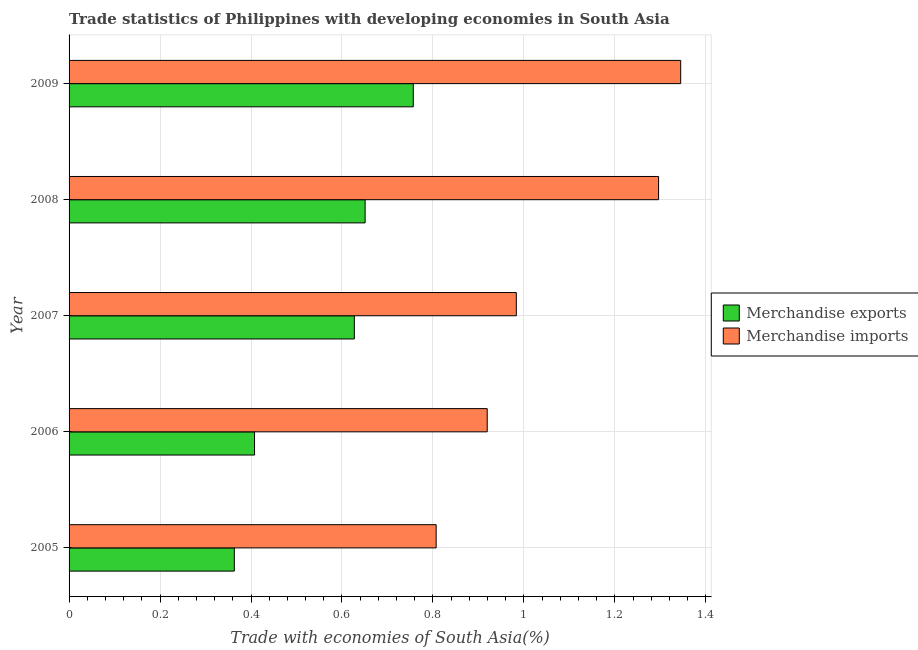How many different coloured bars are there?
Your response must be concise. 2. How many groups of bars are there?
Keep it short and to the point. 5. Are the number of bars per tick equal to the number of legend labels?
Provide a succinct answer. Yes. Are the number of bars on each tick of the Y-axis equal?
Provide a short and direct response. Yes. How many bars are there on the 2nd tick from the top?
Offer a terse response. 2. How many bars are there on the 5th tick from the bottom?
Offer a terse response. 2. In how many cases, is the number of bars for a given year not equal to the number of legend labels?
Offer a very short reply. 0. What is the merchandise imports in 2009?
Make the answer very short. 1.34. Across all years, what is the maximum merchandise exports?
Give a very brief answer. 0.76. Across all years, what is the minimum merchandise exports?
Make the answer very short. 0.36. What is the total merchandise imports in the graph?
Your response must be concise. 5.35. What is the difference between the merchandise exports in 2006 and that in 2009?
Offer a terse response. -0.35. What is the difference between the merchandise exports in 2008 and the merchandise imports in 2005?
Provide a short and direct response. -0.16. What is the average merchandise exports per year?
Keep it short and to the point. 0.56. In the year 2009, what is the difference between the merchandise exports and merchandise imports?
Provide a short and direct response. -0.59. In how many years, is the merchandise exports greater than 0.6000000000000001 %?
Keep it short and to the point. 3. What is the ratio of the merchandise imports in 2005 to that in 2008?
Your response must be concise. 0.62. What is the difference between the highest and the second highest merchandise exports?
Keep it short and to the point. 0.11. What is the difference between the highest and the lowest merchandise exports?
Make the answer very short. 0.39. Are the values on the major ticks of X-axis written in scientific E-notation?
Your response must be concise. No. Does the graph contain any zero values?
Offer a terse response. No. Does the graph contain grids?
Provide a succinct answer. Yes. Where does the legend appear in the graph?
Offer a very short reply. Center right. How are the legend labels stacked?
Offer a very short reply. Vertical. What is the title of the graph?
Offer a very short reply. Trade statistics of Philippines with developing economies in South Asia. Does "Canada" appear as one of the legend labels in the graph?
Your response must be concise. No. What is the label or title of the X-axis?
Your response must be concise. Trade with economies of South Asia(%). What is the label or title of the Y-axis?
Offer a terse response. Year. What is the Trade with economies of South Asia(%) of Merchandise exports in 2005?
Your response must be concise. 0.36. What is the Trade with economies of South Asia(%) in Merchandise imports in 2005?
Give a very brief answer. 0.81. What is the Trade with economies of South Asia(%) of Merchandise exports in 2006?
Your answer should be very brief. 0.41. What is the Trade with economies of South Asia(%) in Merchandise imports in 2006?
Your answer should be very brief. 0.92. What is the Trade with economies of South Asia(%) in Merchandise exports in 2007?
Your answer should be very brief. 0.63. What is the Trade with economies of South Asia(%) in Merchandise imports in 2007?
Offer a terse response. 0.98. What is the Trade with economies of South Asia(%) of Merchandise exports in 2008?
Provide a succinct answer. 0.65. What is the Trade with economies of South Asia(%) in Merchandise imports in 2008?
Provide a succinct answer. 1.3. What is the Trade with economies of South Asia(%) in Merchandise exports in 2009?
Provide a succinct answer. 0.76. What is the Trade with economies of South Asia(%) in Merchandise imports in 2009?
Your response must be concise. 1.34. Across all years, what is the maximum Trade with economies of South Asia(%) in Merchandise exports?
Provide a short and direct response. 0.76. Across all years, what is the maximum Trade with economies of South Asia(%) of Merchandise imports?
Your answer should be compact. 1.34. Across all years, what is the minimum Trade with economies of South Asia(%) of Merchandise exports?
Your answer should be compact. 0.36. Across all years, what is the minimum Trade with economies of South Asia(%) of Merchandise imports?
Your answer should be compact. 0.81. What is the total Trade with economies of South Asia(%) of Merchandise exports in the graph?
Give a very brief answer. 2.81. What is the total Trade with economies of South Asia(%) in Merchandise imports in the graph?
Ensure brevity in your answer.  5.35. What is the difference between the Trade with economies of South Asia(%) of Merchandise exports in 2005 and that in 2006?
Provide a short and direct response. -0.04. What is the difference between the Trade with economies of South Asia(%) in Merchandise imports in 2005 and that in 2006?
Your answer should be compact. -0.11. What is the difference between the Trade with economies of South Asia(%) in Merchandise exports in 2005 and that in 2007?
Offer a terse response. -0.26. What is the difference between the Trade with economies of South Asia(%) of Merchandise imports in 2005 and that in 2007?
Provide a short and direct response. -0.18. What is the difference between the Trade with economies of South Asia(%) of Merchandise exports in 2005 and that in 2008?
Provide a succinct answer. -0.29. What is the difference between the Trade with economies of South Asia(%) of Merchandise imports in 2005 and that in 2008?
Your response must be concise. -0.49. What is the difference between the Trade with economies of South Asia(%) of Merchandise exports in 2005 and that in 2009?
Give a very brief answer. -0.39. What is the difference between the Trade with economies of South Asia(%) of Merchandise imports in 2005 and that in 2009?
Ensure brevity in your answer.  -0.54. What is the difference between the Trade with economies of South Asia(%) in Merchandise exports in 2006 and that in 2007?
Your answer should be compact. -0.22. What is the difference between the Trade with economies of South Asia(%) in Merchandise imports in 2006 and that in 2007?
Your answer should be very brief. -0.06. What is the difference between the Trade with economies of South Asia(%) of Merchandise exports in 2006 and that in 2008?
Make the answer very short. -0.24. What is the difference between the Trade with economies of South Asia(%) of Merchandise imports in 2006 and that in 2008?
Your answer should be compact. -0.38. What is the difference between the Trade with economies of South Asia(%) in Merchandise exports in 2006 and that in 2009?
Make the answer very short. -0.35. What is the difference between the Trade with economies of South Asia(%) in Merchandise imports in 2006 and that in 2009?
Your answer should be very brief. -0.43. What is the difference between the Trade with economies of South Asia(%) in Merchandise exports in 2007 and that in 2008?
Provide a short and direct response. -0.02. What is the difference between the Trade with economies of South Asia(%) of Merchandise imports in 2007 and that in 2008?
Keep it short and to the point. -0.31. What is the difference between the Trade with economies of South Asia(%) of Merchandise exports in 2007 and that in 2009?
Your response must be concise. -0.13. What is the difference between the Trade with economies of South Asia(%) of Merchandise imports in 2007 and that in 2009?
Provide a succinct answer. -0.36. What is the difference between the Trade with economies of South Asia(%) of Merchandise exports in 2008 and that in 2009?
Give a very brief answer. -0.11. What is the difference between the Trade with economies of South Asia(%) in Merchandise imports in 2008 and that in 2009?
Ensure brevity in your answer.  -0.05. What is the difference between the Trade with economies of South Asia(%) of Merchandise exports in 2005 and the Trade with economies of South Asia(%) of Merchandise imports in 2006?
Your response must be concise. -0.56. What is the difference between the Trade with economies of South Asia(%) in Merchandise exports in 2005 and the Trade with economies of South Asia(%) in Merchandise imports in 2007?
Offer a terse response. -0.62. What is the difference between the Trade with economies of South Asia(%) in Merchandise exports in 2005 and the Trade with economies of South Asia(%) in Merchandise imports in 2008?
Offer a terse response. -0.93. What is the difference between the Trade with economies of South Asia(%) in Merchandise exports in 2005 and the Trade with economies of South Asia(%) in Merchandise imports in 2009?
Ensure brevity in your answer.  -0.98. What is the difference between the Trade with economies of South Asia(%) in Merchandise exports in 2006 and the Trade with economies of South Asia(%) in Merchandise imports in 2007?
Give a very brief answer. -0.58. What is the difference between the Trade with economies of South Asia(%) in Merchandise exports in 2006 and the Trade with economies of South Asia(%) in Merchandise imports in 2008?
Offer a terse response. -0.89. What is the difference between the Trade with economies of South Asia(%) of Merchandise exports in 2006 and the Trade with economies of South Asia(%) of Merchandise imports in 2009?
Make the answer very short. -0.94. What is the difference between the Trade with economies of South Asia(%) of Merchandise exports in 2007 and the Trade with economies of South Asia(%) of Merchandise imports in 2008?
Your answer should be very brief. -0.67. What is the difference between the Trade with economies of South Asia(%) in Merchandise exports in 2007 and the Trade with economies of South Asia(%) in Merchandise imports in 2009?
Offer a terse response. -0.72. What is the difference between the Trade with economies of South Asia(%) of Merchandise exports in 2008 and the Trade with economies of South Asia(%) of Merchandise imports in 2009?
Your answer should be compact. -0.69. What is the average Trade with economies of South Asia(%) of Merchandise exports per year?
Give a very brief answer. 0.56. What is the average Trade with economies of South Asia(%) in Merchandise imports per year?
Make the answer very short. 1.07. In the year 2005, what is the difference between the Trade with economies of South Asia(%) in Merchandise exports and Trade with economies of South Asia(%) in Merchandise imports?
Your answer should be very brief. -0.44. In the year 2006, what is the difference between the Trade with economies of South Asia(%) in Merchandise exports and Trade with economies of South Asia(%) in Merchandise imports?
Ensure brevity in your answer.  -0.51. In the year 2007, what is the difference between the Trade with economies of South Asia(%) of Merchandise exports and Trade with economies of South Asia(%) of Merchandise imports?
Offer a very short reply. -0.36. In the year 2008, what is the difference between the Trade with economies of South Asia(%) of Merchandise exports and Trade with economies of South Asia(%) of Merchandise imports?
Make the answer very short. -0.65. In the year 2009, what is the difference between the Trade with economies of South Asia(%) of Merchandise exports and Trade with economies of South Asia(%) of Merchandise imports?
Your answer should be compact. -0.59. What is the ratio of the Trade with economies of South Asia(%) of Merchandise exports in 2005 to that in 2006?
Make the answer very short. 0.89. What is the ratio of the Trade with economies of South Asia(%) of Merchandise imports in 2005 to that in 2006?
Give a very brief answer. 0.88. What is the ratio of the Trade with economies of South Asia(%) of Merchandise exports in 2005 to that in 2007?
Ensure brevity in your answer.  0.58. What is the ratio of the Trade with economies of South Asia(%) in Merchandise imports in 2005 to that in 2007?
Offer a very short reply. 0.82. What is the ratio of the Trade with economies of South Asia(%) in Merchandise exports in 2005 to that in 2008?
Offer a terse response. 0.56. What is the ratio of the Trade with economies of South Asia(%) in Merchandise imports in 2005 to that in 2008?
Your response must be concise. 0.62. What is the ratio of the Trade with economies of South Asia(%) of Merchandise exports in 2005 to that in 2009?
Make the answer very short. 0.48. What is the ratio of the Trade with economies of South Asia(%) in Merchandise imports in 2005 to that in 2009?
Your answer should be compact. 0.6. What is the ratio of the Trade with economies of South Asia(%) in Merchandise exports in 2006 to that in 2007?
Your response must be concise. 0.65. What is the ratio of the Trade with economies of South Asia(%) in Merchandise imports in 2006 to that in 2007?
Your response must be concise. 0.93. What is the ratio of the Trade with economies of South Asia(%) of Merchandise exports in 2006 to that in 2008?
Provide a succinct answer. 0.63. What is the ratio of the Trade with economies of South Asia(%) in Merchandise imports in 2006 to that in 2008?
Your answer should be compact. 0.71. What is the ratio of the Trade with economies of South Asia(%) in Merchandise exports in 2006 to that in 2009?
Offer a very short reply. 0.54. What is the ratio of the Trade with economies of South Asia(%) in Merchandise imports in 2006 to that in 2009?
Offer a very short reply. 0.68. What is the ratio of the Trade with economies of South Asia(%) in Merchandise exports in 2007 to that in 2008?
Provide a succinct answer. 0.96. What is the ratio of the Trade with economies of South Asia(%) in Merchandise imports in 2007 to that in 2008?
Offer a very short reply. 0.76. What is the ratio of the Trade with economies of South Asia(%) in Merchandise exports in 2007 to that in 2009?
Provide a succinct answer. 0.83. What is the ratio of the Trade with economies of South Asia(%) of Merchandise imports in 2007 to that in 2009?
Ensure brevity in your answer.  0.73. What is the ratio of the Trade with economies of South Asia(%) of Merchandise exports in 2008 to that in 2009?
Your response must be concise. 0.86. What is the ratio of the Trade with economies of South Asia(%) of Merchandise imports in 2008 to that in 2009?
Keep it short and to the point. 0.96. What is the difference between the highest and the second highest Trade with economies of South Asia(%) of Merchandise exports?
Your answer should be compact. 0.11. What is the difference between the highest and the second highest Trade with economies of South Asia(%) in Merchandise imports?
Your answer should be compact. 0.05. What is the difference between the highest and the lowest Trade with economies of South Asia(%) in Merchandise exports?
Give a very brief answer. 0.39. What is the difference between the highest and the lowest Trade with economies of South Asia(%) in Merchandise imports?
Your answer should be compact. 0.54. 